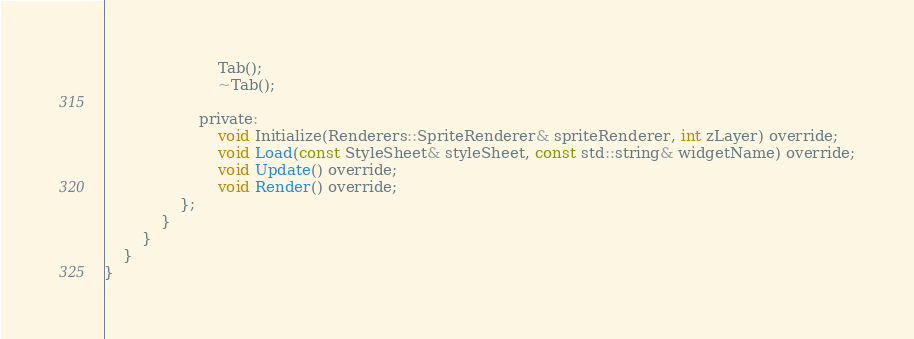<code> <loc_0><loc_0><loc_500><loc_500><_C_>						Tab();
						~Tab();

					private:
						void Initialize(Renderers::SpriteRenderer& spriteRenderer, int zLayer) override;
						void Load(const StyleSheet& styleSheet, const std::string& widgetName) override;
						void Update() override;
						void Render() override;
				};
			}
		}
	}
}</code> 